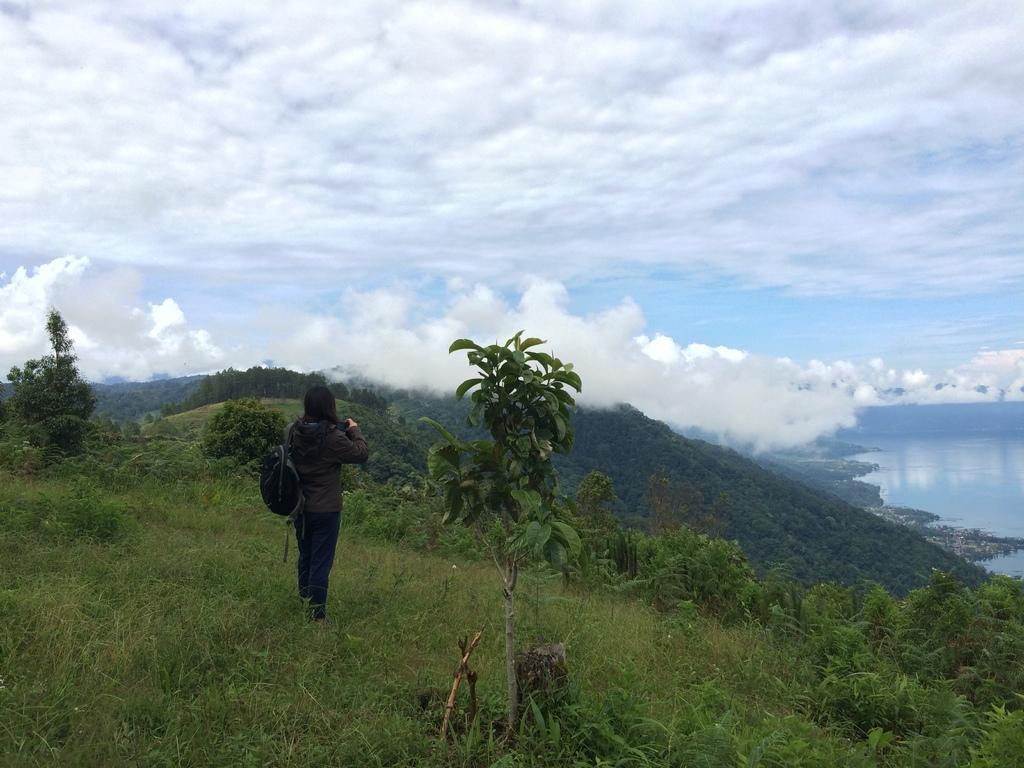Describe this image in one or two sentences. There is a person standing and wire bag. We can see grass and plants. In the background we can see trees,water and sky is cloudy. 